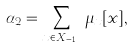<formula> <loc_0><loc_0><loc_500><loc_500>\alpha _ { 2 } = \sum _ { x \in X _ { m - 1 } } \mu _ { x } [ x ] ,</formula> 